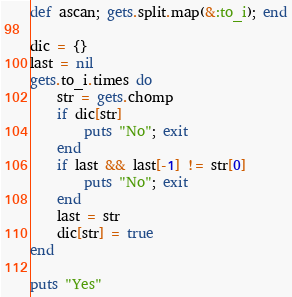<code> <loc_0><loc_0><loc_500><loc_500><_Ruby_>def ascan; gets.split.map(&:to_i); end

dic = {}
last = nil
gets.to_i.times do
    str = gets.chomp
    if dic[str]
        puts "No"; exit
    end
    if last && last[-1] != str[0]
        puts "No"; exit
    end
    last = str
    dic[str] = true
end

puts "Yes"</code> 